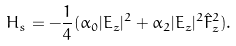<formula> <loc_0><loc_0><loc_500><loc_500>H _ { s } = - \frac { 1 } { 4 } ( \alpha _ { 0 } | E _ { z } | ^ { 2 } + \alpha _ { 2 } | E _ { z } | ^ { 2 } \hat { F } _ { z } ^ { 2 } ) .</formula> 